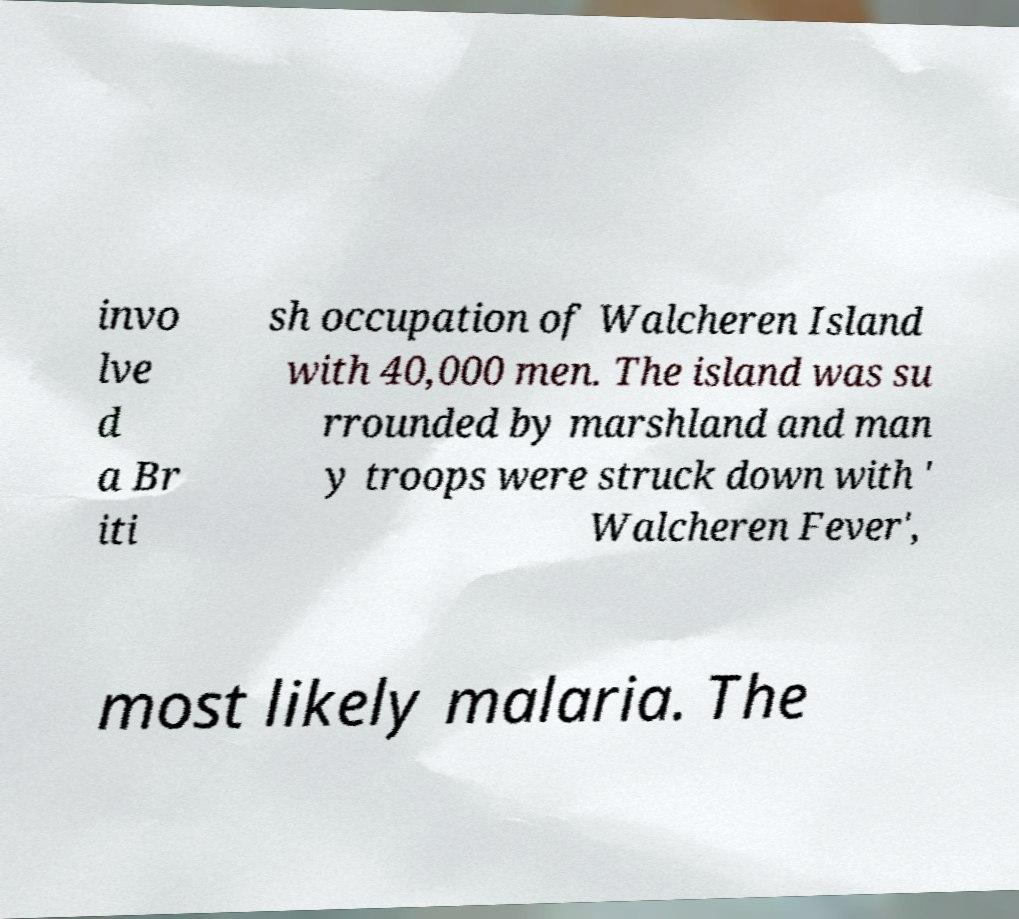Please read and relay the text visible in this image. What does it say? invo lve d a Br iti sh occupation of Walcheren Island with 40,000 men. The island was su rrounded by marshland and man y troops were struck down with ' Walcheren Fever', most likely malaria. The 